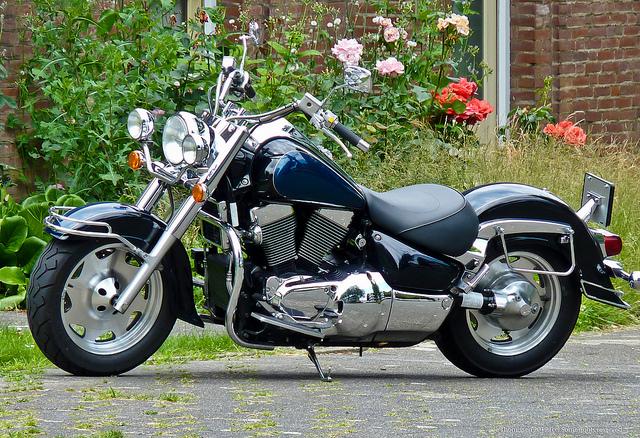How small is the motorcycle?
Short answer required. Not small. Is this a harley motorcycle?
Answer briefly. Yes. What is the primary color of the bike?
Write a very short answer. Blue. What color are the roses?
Concise answer only. Red. What kind of motorcycle is closest?
Short answer required. Harley. Is there a helmet on the motorbike?
Answer briefly. No. Is there a helmet?
Write a very short answer. No. What is the debris under the motorcycle?
Answer briefly. Grass. What color is the motorcycle?
Give a very brief answer. Blue. Are  this colored roses?
Quick response, please. Yes. 